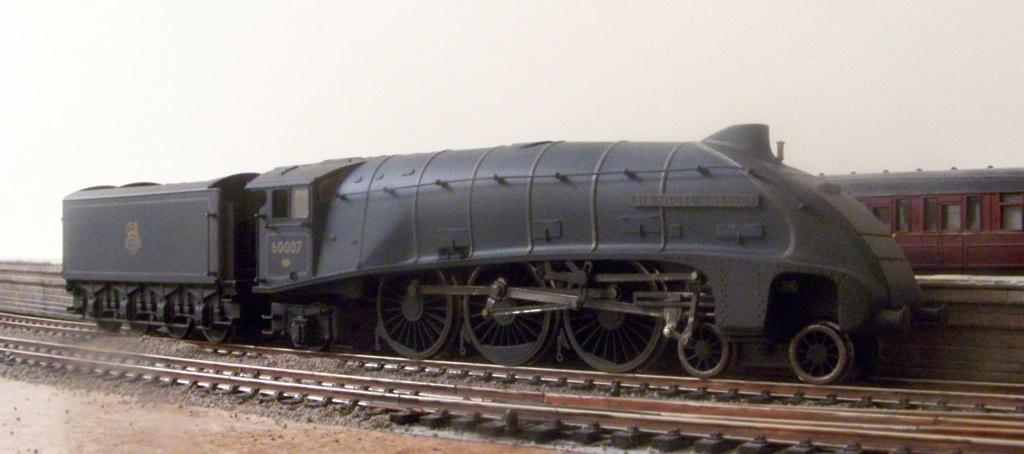What type of vehicles are in the image? There are trains in the image. Where are the trains located? The trains are on railway tracks. What type of terrain is visible in the image? There are stones visible in the image. What can be seen in the background of the image? The sky is visible in the background of the image. How many chickens are sitting on the head of the train conductor in the image? There are no chickens or train conductor present in the image. 